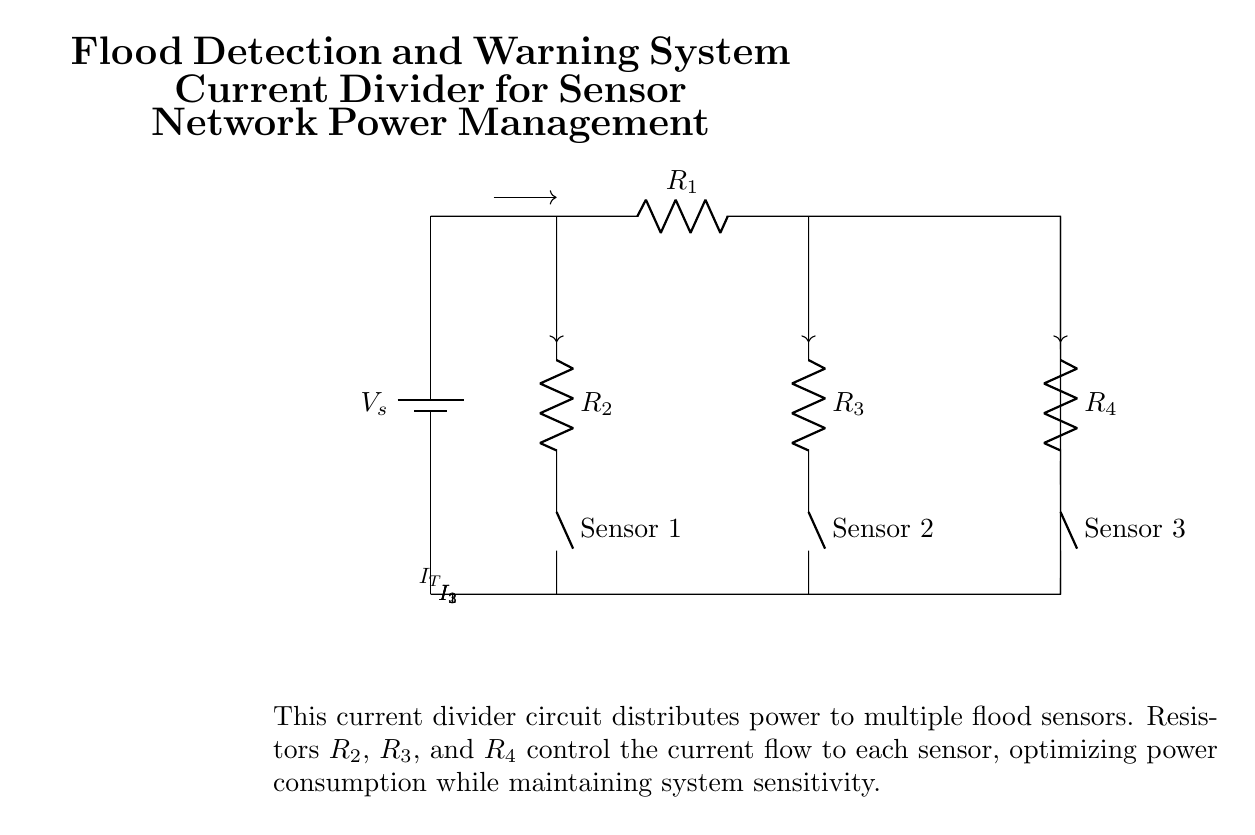What is the power source of this circuit? The power source in the circuit is represented by a battery, labeled V_s, which supplies the necessary voltage for the operation of the current divider.
Answer: Battery What are the components connected to the main current path? The main current path includes the power source battery, a resistor labeled R_1, and the connections leading to other resistors for the sensors.
Answer: Battery and R1 What is the total current entering the circuit? The total current entering the circuit is denoted as I_T, which is the current that flows from the battery into the circuit's main path before being divided by the resistors.
Answer: I_T How many sensors are in this circuit? There are three sensors in the circuit, indicated by the connections to resistors R_2, R_3, and R_4, each labeled as a different sensor.
Answer: Three Which resistor controls the current to Sensor 1? The current to Sensor 1 is controlled by resistor R_2, as it is directly connected in series with Sensor 1 in the circuit.
Answer: R_2 What is the purpose of the resistors in this current divider? The purpose of the resistors in this current divider is to control and optimize the distribution of current to each flood sensor, ensuring efficient power management while maintaining their sensitivity.
Answer: Control current distribution What is the relationship between the resistors and the amount of current flowing to each sensor? The relationship is based on Ohm's Law and the current divider rule, where the current flowing to each sensor is inversely proportional to its resistance; lower resistance leads to higher current flow.
Answer: Inversely proportional 